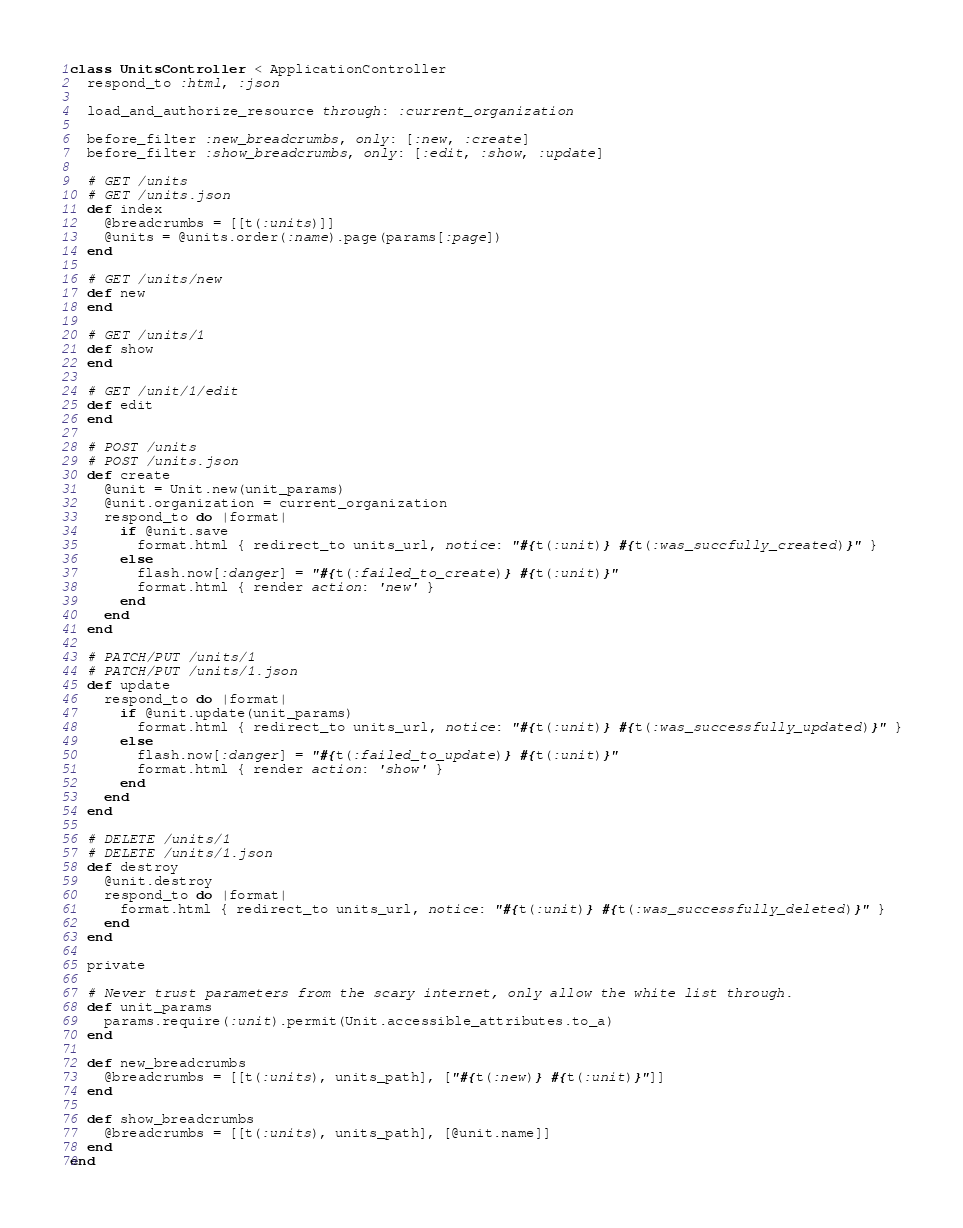Convert code to text. <code><loc_0><loc_0><loc_500><loc_500><_Ruby_>class UnitsController < ApplicationController
  respond_to :html, :json

  load_and_authorize_resource through: :current_organization

  before_filter :new_breadcrumbs, only: [:new, :create]
  before_filter :show_breadcrumbs, only: [:edit, :show, :update]

  # GET /units
  # GET /units.json
  def index
    @breadcrumbs = [[t(:units)]]
    @units = @units.order(:name).page(params[:page])
  end

  # GET /units/new
  def new
  end

  # GET /units/1
  def show
  end

  # GET /unit/1/edit
  def edit
  end

  # POST /units
  # POST /units.json
  def create
    @unit = Unit.new(unit_params)
    @unit.organization = current_organization
    respond_to do |format|
      if @unit.save
        format.html { redirect_to units_url, notice: "#{t(:unit)} #{t(:was_succfully_created)}" }
      else
        flash.now[:danger] = "#{t(:failed_to_create)} #{t(:unit)}"
        format.html { render action: 'new' }
      end
    end
  end

  # PATCH/PUT /units/1
  # PATCH/PUT /units/1.json
  def update
    respond_to do |format|
      if @unit.update(unit_params)
        format.html { redirect_to units_url, notice: "#{t(:unit)} #{t(:was_successfully_updated)}" }
      else
        flash.now[:danger] = "#{t(:failed_to_update)} #{t(:unit)}"
        format.html { render action: 'show' }
      end
    end
  end

  # DELETE /units/1
  # DELETE /units/1.json
  def destroy
    @unit.destroy
    respond_to do |format|
      format.html { redirect_to units_url, notice: "#{t(:unit)} #{t(:was_successfully_deleted)}" }
    end
  end

  private

  # Never trust parameters from the scary internet, only allow the white list through.
  def unit_params
    params.require(:unit).permit(Unit.accessible_attributes.to_a)
  end

  def new_breadcrumbs
    @breadcrumbs = [[t(:units), units_path], ["#{t(:new)} #{t(:unit)}"]]
  end

  def show_breadcrumbs
    @breadcrumbs = [[t(:units), units_path], [@unit.name]]
  end
end
</code> 